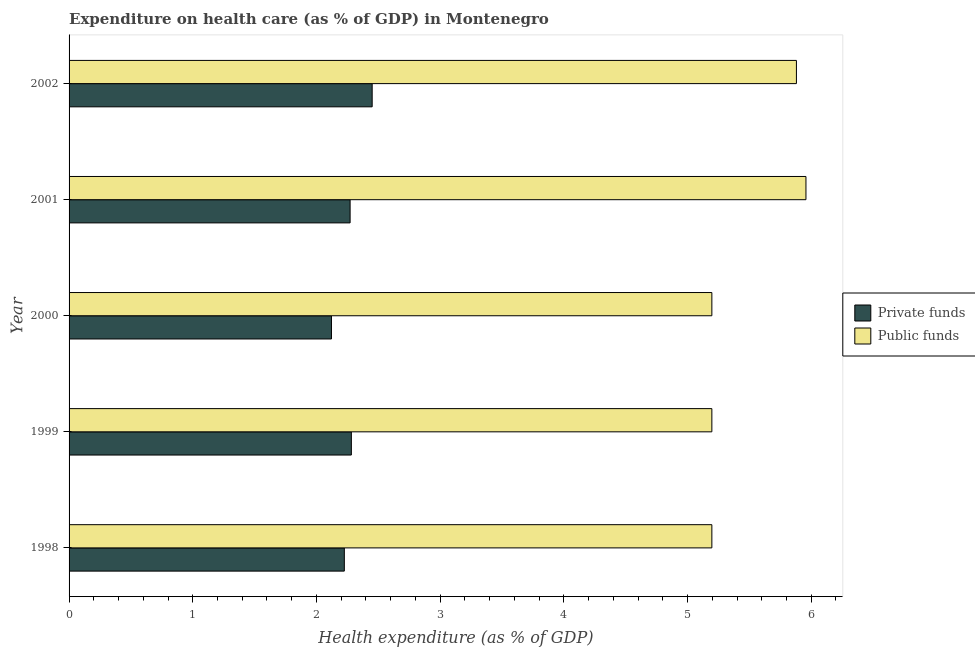Are the number of bars per tick equal to the number of legend labels?
Your answer should be very brief. Yes. Are the number of bars on each tick of the Y-axis equal?
Provide a short and direct response. Yes. How many bars are there on the 1st tick from the bottom?
Your response must be concise. 2. What is the amount of private funds spent in healthcare in 2000?
Give a very brief answer. 2.12. Across all years, what is the maximum amount of public funds spent in healthcare?
Give a very brief answer. 5.96. Across all years, what is the minimum amount of public funds spent in healthcare?
Make the answer very short. 5.2. In which year was the amount of public funds spent in healthcare maximum?
Offer a terse response. 2001. What is the total amount of private funds spent in healthcare in the graph?
Your response must be concise. 11.35. What is the difference between the amount of public funds spent in healthcare in 2000 and that in 2002?
Keep it short and to the point. -0.68. What is the difference between the amount of private funds spent in healthcare in 1999 and the amount of public funds spent in healthcare in 2001?
Your answer should be very brief. -3.68. What is the average amount of private funds spent in healthcare per year?
Your response must be concise. 2.27. In the year 2001, what is the difference between the amount of private funds spent in healthcare and amount of public funds spent in healthcare?
Your answer should be very brief. -3.69. What is the ratio of the amount of private funds spent in healthcare in 1999 to that in 2000?
Your response must be concise. 1.08. Is the amount of private funds spent in healthcare in 1999 less than that in 2002?
Your answer should be very brief. Yes. Is the difference between the amount of private funds spent in healthcare in 1999 and 2001 greater than the difference between the amount of public funds spent in healthcare in 1999 and 2001?
Your answer should be compact. Yes. What is the difference between the highest and the second highest amount of public funds spent in healthcare?
Ensure brevity in your answer.  0.08. What is the difference between the highest and the lowest amount of public funds spent in healthcare?
Ensure brevity in your answer.  0.76. In how many years, is the amount of private funds spent in healthcare greater than the average amount of private funds spent in healthcare taken over all years?
Offer a terse response. 3. What does the 2nd bar from the top in 2001 represents?
Provide a short and direct response. Private funds. What does the 2nd bar from the bottom in 2000 represents?
Your response must be concise. Public funds. How many bars are there?
Your response must be concise. 10. Are all the bars in the graph horizontal?
Provide a short and direct response. Yes. Where does the legend appear in the graph?
Offer a very short reply. Center right. How many legend labels are there?
Give a very brief answer. 2. How are the legend labels stacked?
Make the answer very short. Vertical. What is the title of the graph?
Offer a very short reply. Expenditure on health care (as % of GDP) in Montenegro. Does "Total Population" appear as one of the legend labels in the graph?
Make the answer very short. No. What is the label or title of the X-axis?
Ensure brevity in your answer.  Health expenditure (as % of GDP). What is the label or title of the Y-axis?
Make the answer very short. Year. What is the Health expenditure (as % of GDP) in Private funds in 1998?
Provide a succinct answer. 2.23. What is the Health expenditure (as % of GDP) of Public funds in 1998?
Your answer should be very brief. 5.2. What is the Health expenditure (as % of GDP) in Private funds in 1999?
Offer a very short reply. 2.28. What is the Health expenditure (as % of GDP) in Public funds in 1999?
Give a very brief answer. 5.2. What is the Health expenditure (as % of GDP) of Private funds in 2000?
Keep it short and to the point. 2.12. What is the Health expenditure (as % of GDP) of Public funds in 2000?
Make the answer very short. 5.2. What is the Health expenditure (as % of GDP) in Private funds in 2001?
Your answer should be very brief. 2.27. What is the Health expenditure (as % of GDP) in Public funds in 2001?
Provide a short and direct response. 5.96. What is the Health expenditure (as % of GDP) of Private funds in 2002?
Offer a very short reply. 2.45. What is the Health expenditure (as % of GDP) of Public funds in 2002?
Offer a very short reply. 5.88. Across all years, what is the maximum Health expenditure (as % of GDP) of Private funds?
Your answer should be compact. 2.45. Across all years, what is the maximum Health expenditure (as % of GDP) in Public funds?
Ensure brevity in your answer.  5.96. Across all years, what is the minimum Health expenditure (as % of GDP) of Private funds?
Make the answer very short. 2.12. Across all years, what is the minimum Health expenditure (as % of GDP) in Public funds?
Make the answer very short. 5.2. What is the total Health expenditure (as % of GDP) of Private funds in the graph?
Make the answer very short. 11.35. What is the total Health expenditure (as % of GDP) of Public funds in the graph?
Your answer should be very brief. 27.43. What is the difference between the Health expenditure (as % of GDP) in Private funds in 1998 and that in 1999?
Offer a very short reply. -0.06. What is the difference between the Health expenditure (as % of GDP) of Public funds in 1998 and that in 1999?
Provide a succinct answer. 0. What is the difference between the Health expenditure (as % of GDP) in Private funds in 1998 and that in 2000?
Offer a very short reply. 0.1. What is the difference between the Health expenditure (as % of GDP) of Private funds in 1998 and that in 2001?
Your response must be concise. -0.05. What is the difference between the Health expenditure (as % of GDP) of Public funds in 1998 and that in 2001?
Keep it short and to the point. -0.76. What is the difference between the Health expenditure (as % of GDP) in Private funds in 1998 and that in 2002?
Keep it short and to the point. -0.23. What is the difference between the Health expenditure (as % of GDP) of Public funds in 1998 and that in 2002?
Provide a succinct answer. -0.68. What is the difference between the Health expenditure (as % of GDP) in Private funds in 1999 and that in 2000?
Provide a succinct answer. 0.16. What is the difference between the Health expenditure (as % of GDP) in Public funds in 1999 and that in 2000?
Your response must be concise. -0. What is the difference between the Health expenditure (as % of GDP) of Public funds in 1999 and that in 2001?
Offer a very short reply. -0.76. What is the difference between the Health expenditure (as % of GDP) of Private funds in 1999 and that in 2002?
Your answer should be compact. -0.17. What is the difference between the Health expenditure (as % of GDP) of Public funds in 1999 and that in 2002?
Make the answer very short. -0.68. What is the difference between the Health expenditure (as % of GDP) in Private funds in 2000 and that in 2001?
Provide a succinct answer. -0.15. What is the difference between the Health expenditure (as % of GDP) of Public funds in 2000 and that in 2001?
Provide a succinct answer. -0.76. What is the difference between the Health expenditure (as % of GDP) of Private funds in 2000 and that in 2002?
Offer a terse response. -0.33. What is the difference between the Health expenditure (as % of GDP) of Public funds in 2000 and that in 2002?
Keep it short and to the point. -0.68. What is the difference between the Health expenditure (as % of GDP) of Private funds in 2001 and that in 2002?
Provide a succinct answer. -0.18. What is the difference between the Health expenditure (as % of GDP) of Public funds in 2001 and that in 2002?
Provide a succinct answer. 0.08. What is the difference between the Health expenditure (as % of GDP) in Private funds in 1998 and the Health expenditure (as % of GDP) in Public funds in 1999?
Give a very brief answer. -2.97. What is the difference between the Health expenditure (as % of GDP) in Private funds in 1998 and the Health expenditure (as % of GDP) in Public funds in 2000?
Your answer should be compact. -2.97. What is the difference between the Health expenditure (as % of GDP) of Private funds in 1998 and the Health expenditure (as % of GDP) of Public funds in 2001?
Your response must be concise. -3.73. What is the difference between the Health expenditure (as % of GDP) of Private funds in 1998 and the Health expenditure (as % of GDP) of Public funds in 2002?
Your answer should be very brief. -3.65. What is the difference between the Health expenditure (as % of GDP) of Private funds in 1999 and the Health expenditure (as % of GDP) of Public funds in 2000?
Your response must be concise. -2.91. What is the difference between the Health expenditure (as % of GDP) of Private funds in 1999 and the Health expenditure (as % of GDP) of Public funds in 2001?
Offer a very short reply. -3.68. What is the difference between the Health expenditure (as % of GDP) in Private funds in 1999 and the Health expenditure (as % of GDP) in Public funds in 2002?
Give a very brief answer. -3.6. What is the difference between the Health expenditure (as % of GDP) in Private funds in 2000 and the Health expenditure (as % of GDP) in Public funds in 2001?
Ensure brevity in your answer.  -3.84. What is the difference between the Health expenditure (as % of GDP) of Private funds in 2000 and the Health expenditure (as % of GDP) of Public funds in 2002?
Make the answer very short. -3.76. What is the difference between the Health expenditure (as % of GDP) in Private funds in 2001 and the Health expenditure (as % of GDP) in Public funds in 2002?
Ensure brevity in your answer.  -3.61. What is the average Health expenditure (as % of GDP) in Private funds per year?
Make the answer very short. 2.27. What is the average Health expenditure (as % of GDP) of Public funds per year?
Your answer should be very brief. 5.49. In the year 1998, what is the difference between the Health expenditure (as % of GDP) in Private funds and Health expenditure (as % of GDP) in Public funds?
Your answer should be compact. -2.97. In the year 1999, what is the difference between the Health expenditure (as % of GDP) of Private funds and Health expenditure (as % of GDP) of Public funds?
Offer a very short reply. -2.91. In the year 2000, what is the difference between the Health expenditure (as % of GDP) in Private funds and Health expenditure (as % of GDP) in Public funds?
Your answer should be compact. -3.08. In the year 2001, what is the difference between the Health expenditure (as % of GDP) of Private funds and Health expenditure (as % of GDP) of Public funds?
Provide a short and direct response. -3.69. In the year 2002, what is the difference between the Health expenditure (as % of GDP) in Private funds and Health expenditure (as % of GDP) in Public funds?
Your response must be concise. -3.43. What is the ratio of the Health expenditure (as % of GDP) of Private funds in 1998 to that in 1999?
Make the answer very short. 0.98. What is the ratio of the Health expenditure (as % of GDP) in Public funds in 1998 to that in 1999?
Give a very brief answer. 1. What is the ratio of the Health expenditure (as % of GDP) of Private funds in 1998 to that in 2000?
Your response must be concise. 1.05. What is the ratio of the Health expenditure (as % of GDP) of Private funds in 1998 to that in 2001?
Offer a very short reply. 0.98. What is the ratio of the Health expenditure (as % of GDP) of Public funds in 1998 to that in 2001?
Your answer should be very brief. 0.87. What is the ratio of the Health expenditure (as % of GDP) in Private funds in 1998 to that in 2002?
Your response must be concise. 0.91. What is the ratio of the Health expenditure (as % of GDP) in Public funds in 1998 to that in 2002?
Offer a very short reply. 0.88. What is the ratio of the Health expenditure (as % of GDP) in Private funds in 1999 to that in 2000?
Your answer should be very brief. 1.08. What is the ratio of the Health expenditure (as % of GDP) in Public funds in 1999 to that in 2000?
Give a very brief answer. 1. What is the ratio of the Health expenditure (as % of GDP) in Private funds in 1999 to that in 2001?
Make the answer very short. 1. What is the ratio of the Health expenditure (as % of GDP) of Public funds in 1999 to that in 2001?
Your response must be concise. 0.87. What is the ratio of the Health expenditure (as % of GDP) of Private funds in 1999 to that in 2002?
Provide a succinct answer. 0.93. What is the ratio of the Health expenditure (as % of GDP) of Public funds in 1999 to that in 2002?
Offer a terse response. 0.88. What is the ratio of the Health expenditure (as % of GDP) of Private funds in 2000 to that in 2001?
Make the answer very short. 0.93. What is the ratio of the Health expenditure (as % of GDP) in Public funds in 2000 to that in 2001?
Give a very brief answer. 0.87. What is the ratio of the Health expenditure (as % of GDP) in Private funds in 2000 to that in 2002?
Provide a short and direct response. 0.87. What is the ratio of the Health expenditure (as % of GDP) of Public funds in 2000 to that in 2002?
Keep it short and to the point. 0.88. What is the ratio of the Health expenditure (as % of GDP) of Private funds in 2001 to that in 2002?
Keep it short and to the point. 0.93. What is the ratio of the Health expenditure (as % of GDP) of Public funds in 2001 to that in 2002?
Your answer should be compact. 1.01. What is the difference between the highest and the second highest Health expenditure (as % of GDP) of Private funds?
Offer a terse response. 0.17. What is the difference between the highest and the second highest Health expenditure (as % of GDP) of Public funds?
Offer a very short reply. 0.08. What is the difference between the highest and the lowest Health expenditure (as % of GDP) in Private funds?
Offer a very short reply. 0.33. What is the difference between the highest and the lowest Health expenditure (as % of GDP) of Public funds?
Offer a terse response. 0.76. 